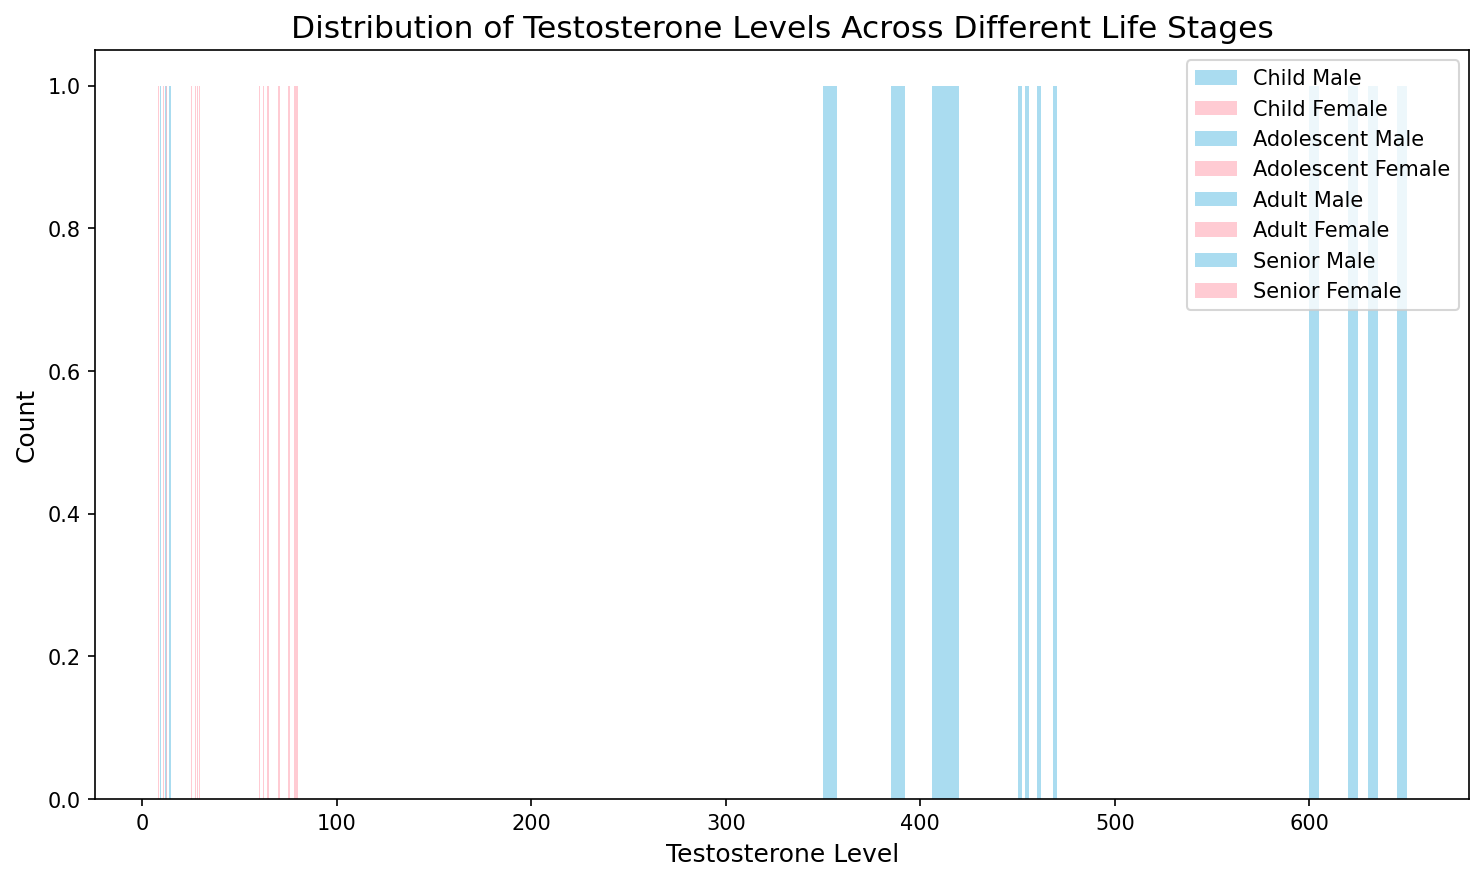Which age group shows the greatest difference in testosterone levels between males and females? By observing the width and height of the histograms for each age group, we see that adolescents exhibit the greatest difference where male testosterone levels are significantly higher (peaking around 400) compared to females (peaking around 30).
Answer: Adolescents Which age group has the highest average testosterone level in males? By examining the peaks of the histograms, the adult males show the highest testosterone levels with values around 600-650.
Answer: Adults How does the testosterone level distribution of adult males compare to that of senior males? Adult males have a higher testosterone level distribution (around 600-650) compared to senior males (around 450-470), indicating a decrease in testosterone with age.
Answer: Higher in adults What is the testosterone distribution difference between child males and child females? Both child males and females have close testosterone levels, although males have a slightly higher distribution (9 to 15) compared to females (8 to 13).
Answer: Males slightly higher Is there an overlap in the testosterone level distribution between adolescent males and adolescent females? By observing the histograms, there is little to no overlap between adolescent males (350-420) and females (25-30).
Answer: No significant overlap Which gender shows a more consistent testosterone distribution in any age group? Female histograms for each age group are more narrow and uniformly spread than male histograms, indicating a more consistent testosterone distribution in females.
Answer: Females How do the testosterone levels of senior females compare visually to those of child males? Both have similar testosterone levels visually; child males range from 9-15, while senior females range from 60-65. However, testosterone levels for senior females are slightly higher.
Answer: Similar but higher in senior females Which age group of females has the widest range of testosterone levels? Adolescent females show the widest range of testosterone levels (around 25-30), compared to other age groups which are more concentrated.
Answer: Adolescents What is the range of testosterone levels in senior males? The histogram for senior males shows testosterone levels ranging from about 450 to 470.
Answer: 450-470 How do child females' testosterone levels change as they age into adolescence? By comparing the child females' histogram (8-13) to the adolescent females' histogram (25-30), there is an increase in testosterone levels as they transition from childhood to adolescence.
Answer: Increases 